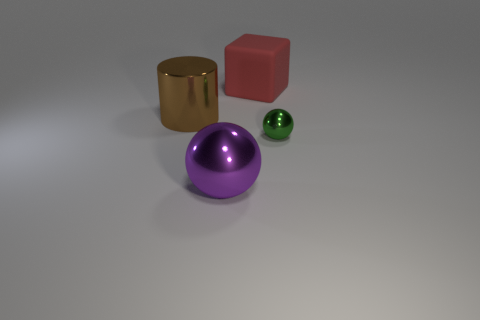Are there any other things that are the same size as the green object?
Your answer should be compact. No. How many other tiny green objects have the same shape as the tiny green metallic object?
Ensure brevity in your answer.  0. What size is the purple sphere that is made of the same material as the large brown thing?
Keep it short and to the point. Large. Is the number of tiny spheres greater than the number of objects?
Offer a very short reply. No. There is a big thing that is in front of the small object; what is its color?
Make the answer very short. Purple. There is a metal thing that is on the right side of the metal cylinder and behind the purple sphere; what size is it?
Offer a very short reply. Small. What number of red things are the same size as the cylinder?
Your answer should be very brief. 1. There is another large object that is the same shape as the green metallic object; what material is it?
Offer a terse response. Metal. Do the red matte object and the tiny green object have the same shape?
Provide a short and direct response. No. There is a large brown thing; what number of big cylinders are to the left of it?
Give a very brief answer. 0. 